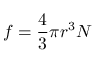Convert formula to latex. <formula><loc_0><loc_0><loc_500><loc_500>f = { \frac { 4 } { 3 } } \pi r ^ { 3 } N \,</formula> 